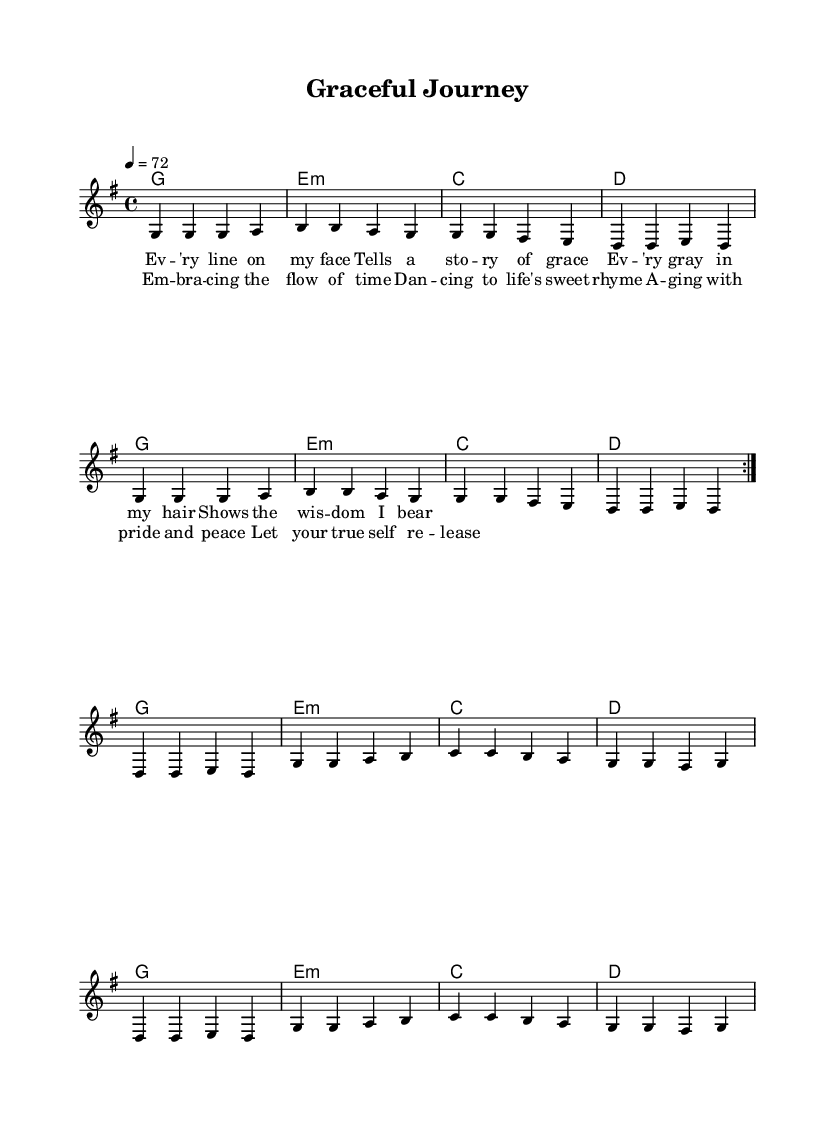What is the key signature of this music? The key signature is G major, which has one sharp (F#). This is indicated at the beginning of the staff.
Answer: G major What is the time signature of this music? The time signature is 4/4, which means there are four beats in each measure and a quarter note receives one beat. This can be found at the start of the piece.
Answer: 4/4 What is the tempo marking of the music? The tempo marking is 72 beats per minute, which states the speed at which the music should be played. This is indicated in the markings above the staff.
Answer: 72 How many verses are in the music? There is one verse followed by a chorus; while verses often repeat, the structure here only shows one labeled verse.
Answer: 1 What is the overall theme of the lyrics? The theme of the lyrics revolves around embracing aging gracefully and appreciating the wisdom that comes with it. The idea is captured in phrases about grace, wisdom, and releasing one's true self.
Answer: Embracing aging What chord follows the first line of the verse? The chord following the first line "Ev -- 'ry line on my face" is a G major chord, clearly marked in the chordal part underneath the lyrics.
Answer: G Which line in the chorus reflects acceptance? The line "Let your true self re -- lease" reflects acceptance of one's true self and aligns with the theme of embracing aging peacefully.
Answer: Let your true self re -- lease 